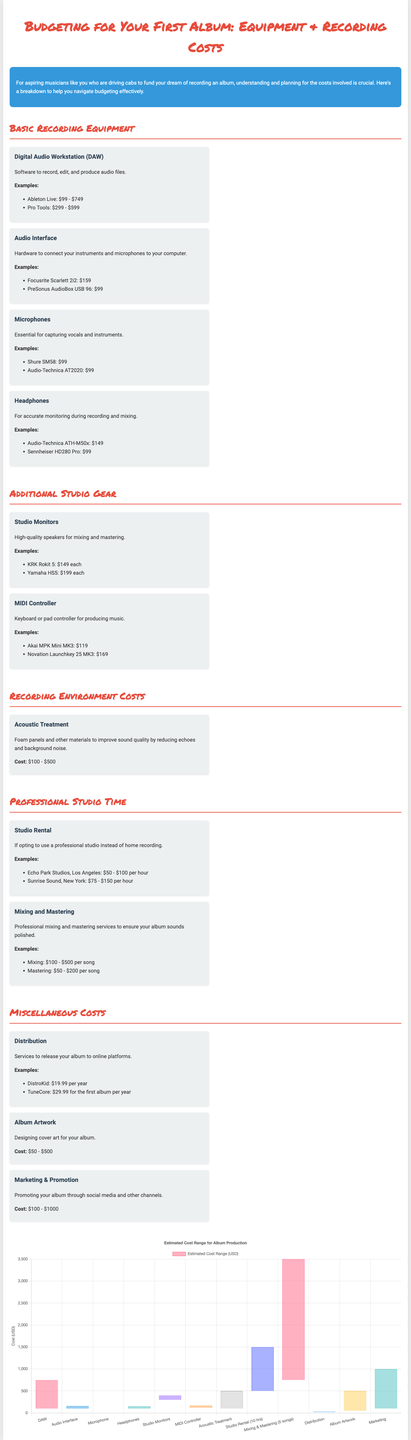What is the estimated cost range for a Digital Audio Workstation (DAW)? The cost range for a DAW is provided in the document, specifically listed as $99 - $749.
Answer: $99 - $749 What is the price of the Focusrite Scarlett 2i2? The price for the Focusrite Scarlett 2i2 is mentioned as $159.
Answer: $159 How much does mixing a song cost? The document states that mixing costs between $100 - $500 per song.
Answer: $100 - $500 What is the estimated cost range for studio rental for 10 hours? The studio rental cost range for 10 hours is discussed, ranging from $500 - $1500.
Answer: $500 - $1500 How much does album artwork design cost? The document specifies that album artwork designing costs between $50 - $500.
Answer: $50 - $500 Which MIDI Controller is listed as an example? The examples provided in the document include the Akai MPK Mini MK3 and Novation Launchkey 25 MK3 for the MIDI Controller section.
Answer: Akai MPK Mini MK3, Novation Launchkey 25 MK3 What is a suggested acoustic treatment cost range? The cost for acoustic treatment is designated in the document as $100 - $500.
Answer: $100 - $500 What are the total costs associated with marketing? The document outlines that marketing and promotion costs can vary between $100 - $1000.
Answer: $100 - $1000 What type of chart is used in the document? The document utilizes a bar chart to represent the estimated cost ranges for album production.
Answer: Bar chart 